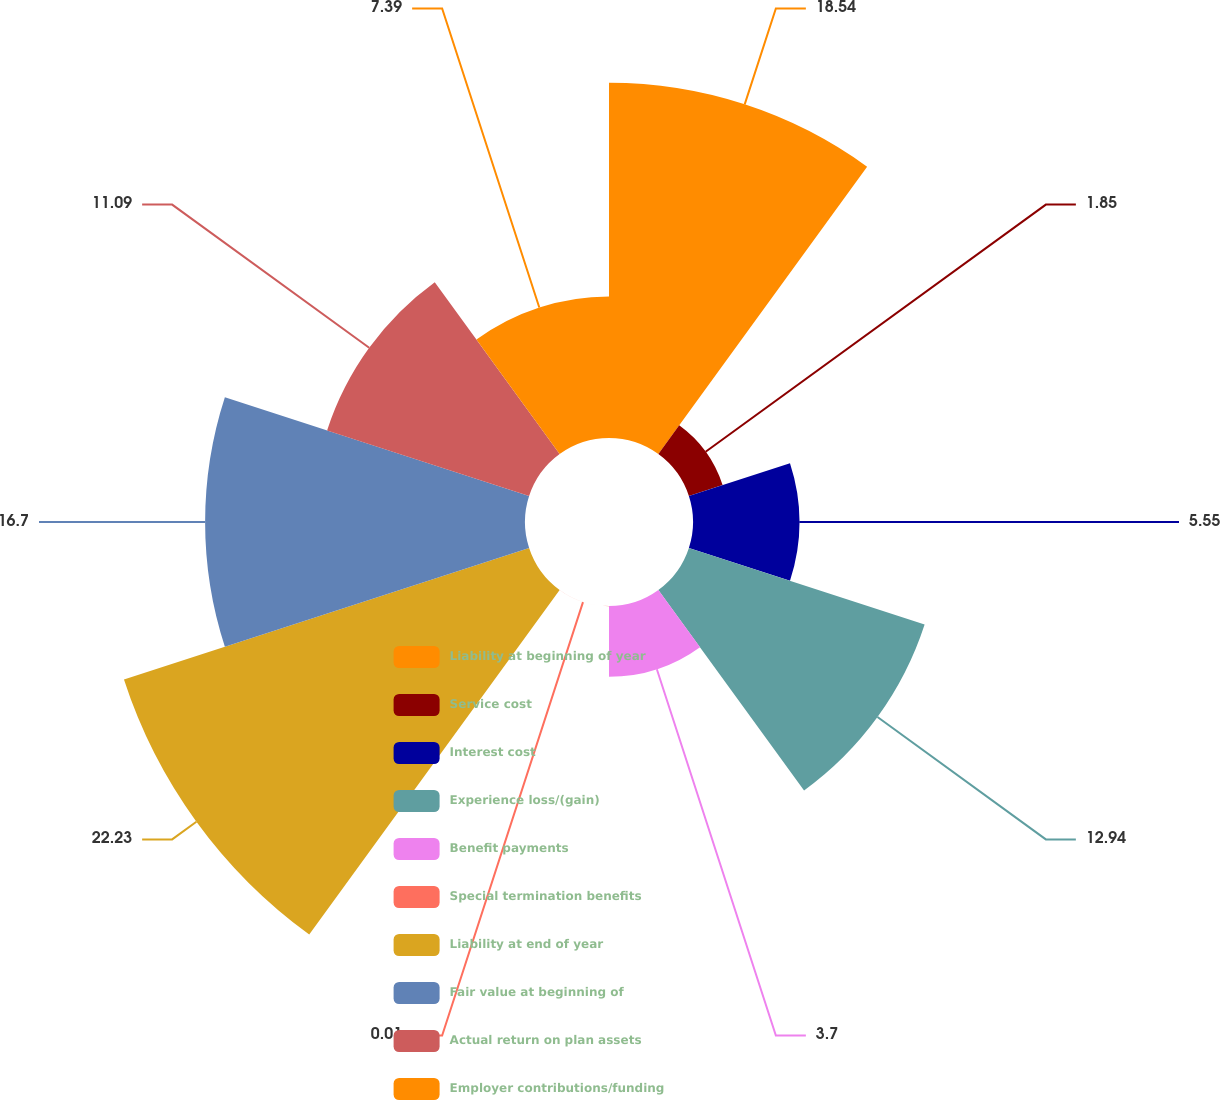Convert chart to OTSL. <chart><loc_0><loc_0><loc_500><loc_500><pie_chart><fcel>Liability at beginning of year<fcel>Service cost<fcel>Interest cost<fcel>Experience loss/(gain)<fcel>Benefit payments<fcel>Special termination benefits<fcel>Liability at end of year<fcel>Fair value at beginning of<fcel>Actual return on plan assets<fcel>Employer contributions/funding<nl><fcel>18.54%<fcel>1.85%<fcel>5.55%<fcel>12.94%<fcel>3.7%<fcel>0.01%<fcel>22.24%<fcel>16.7%<fcel>11.09%<fcel>7.39%<nl></chart> 